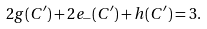Convert formula to latex. <formula><loc_0><loc_0><loc_500><loc_500>2 g ( C ^ { \prime } ) + 2 e _ { - } ( C ^ { \prime } ) + h ( C ^ { \prime } ) = 3 .</formula> 